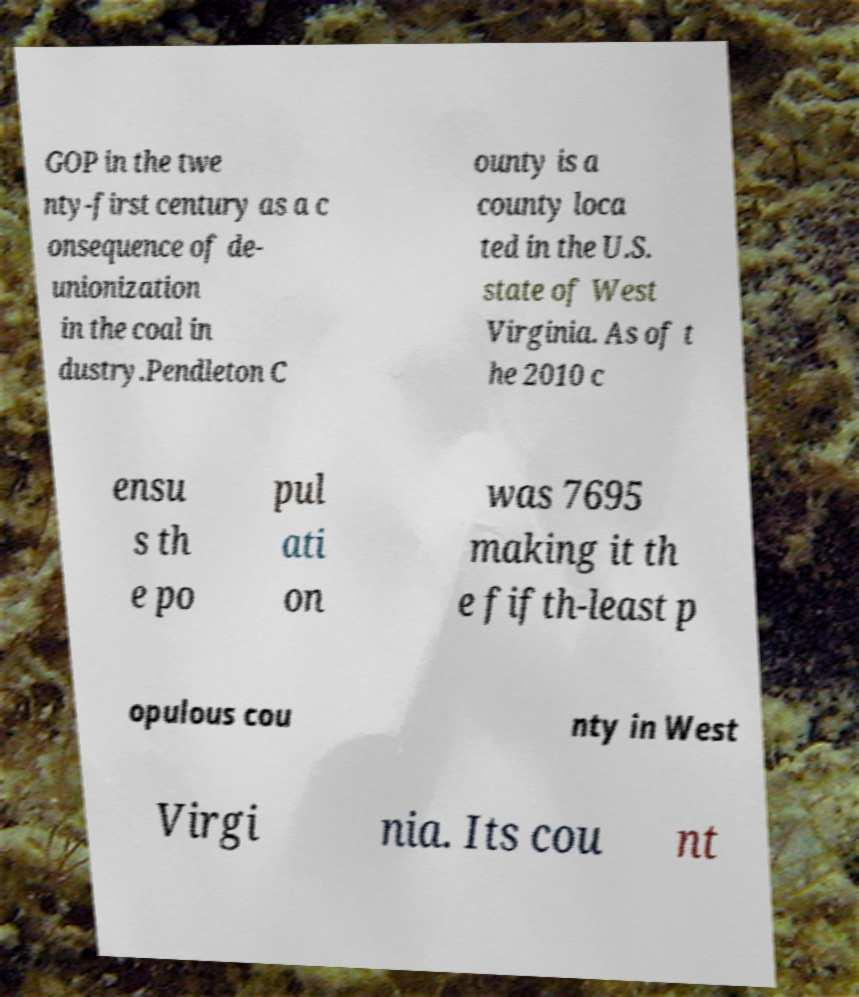Can you accurately transcribe the text from the provided image for me? GOP in the twe nty-first century as a c onsequence of de- unionization in the coal in dustry.Pendleton C ounty is a county loca ted in the U.S. state of West Virginia. As of t he 2010 c ensu s th e po pul ati on was 7695 making it th e fifth-least p opulous cou nty in West Virgi nia. Its cou nt 